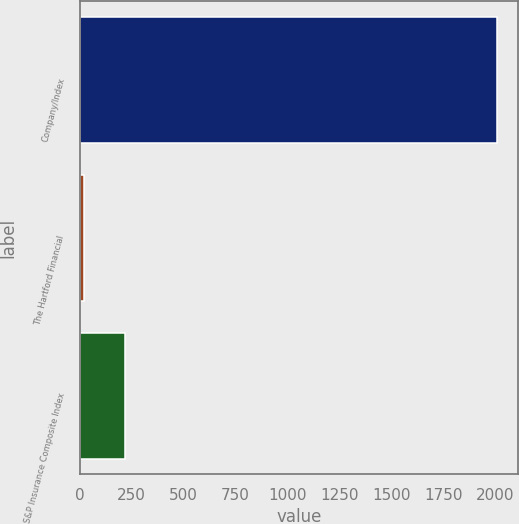Convert chart to OTSL. <chart><loc_0><loc_0><loc_500><loc_500><bar_chart><fcel>Company/Index<fcel>The Hartford Financial<fcel>S&P Insurance Composite Index<nl><fcel>2008<fcel>19.1<fcel>217.99<nl></chart> 